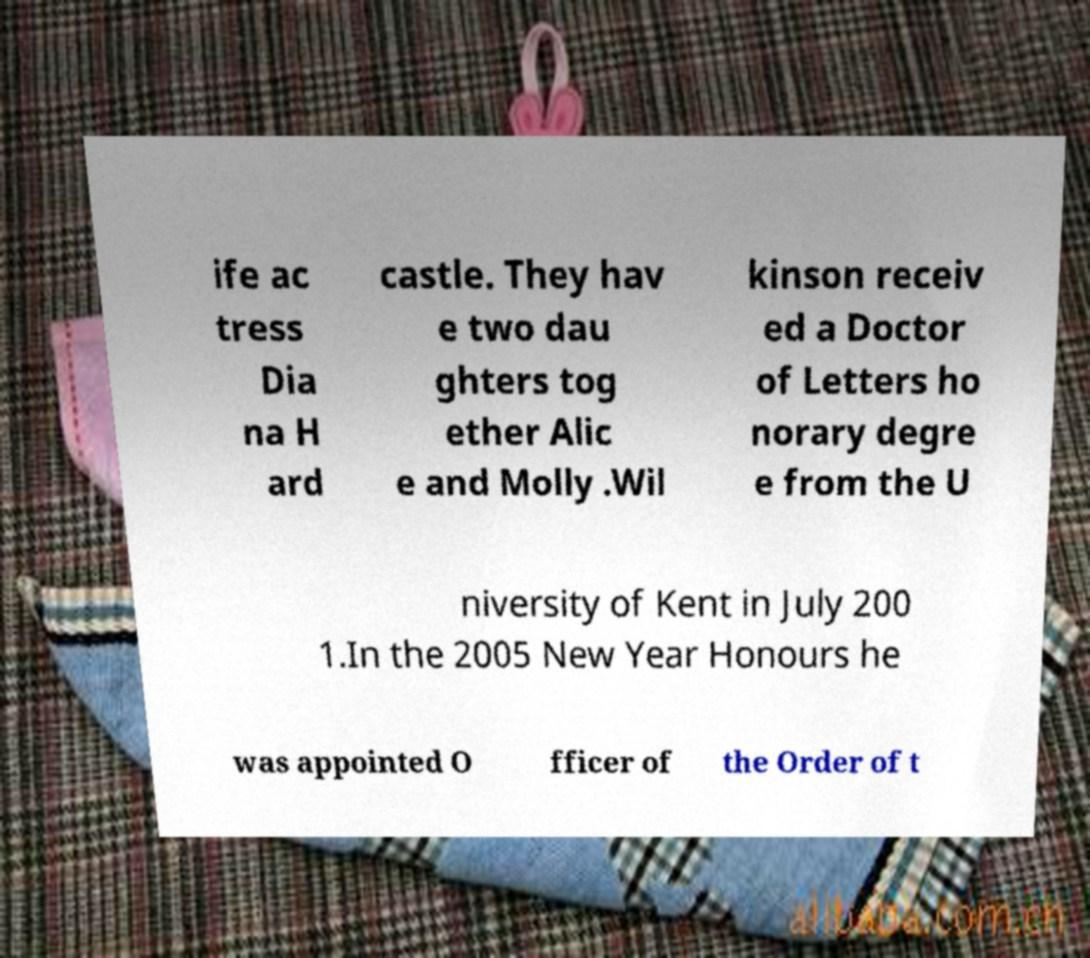Please read and relay the text visible in this image. What does it say? ife ac tress Dia na H ard castle. They hav e two dau ghters tog ether Alic e and Molly .Wil kinson receiv ed a Doctor of Letters ho norary degre e from the U niversity of Kent in July 200 1.In the 2005 New Year Honours he was appointed O fficer of the Order of t 